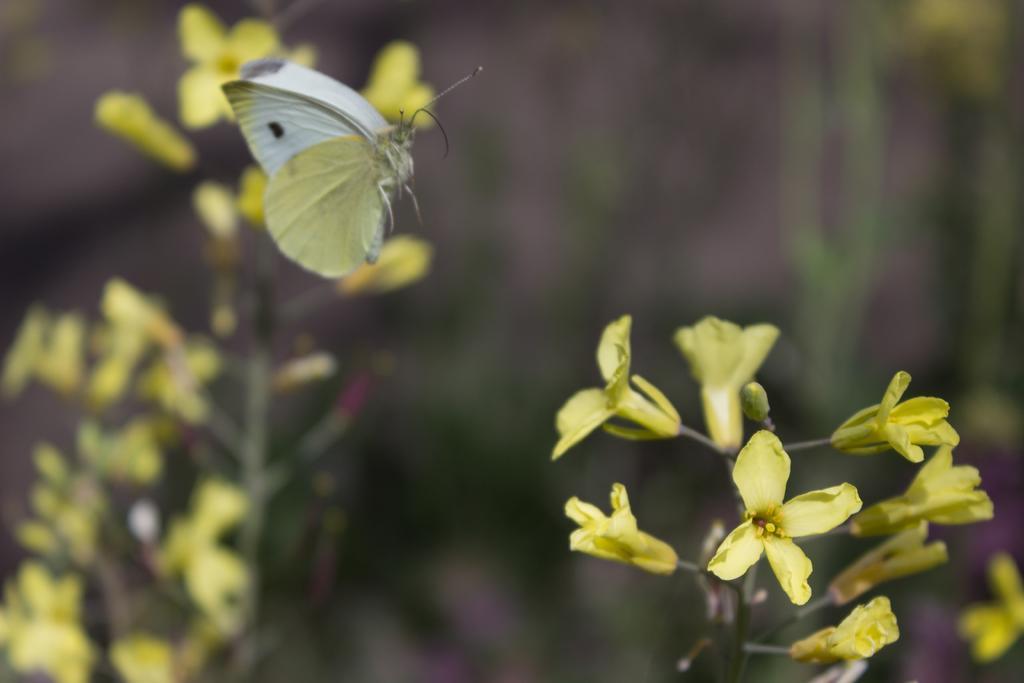In one or two sentences, can you explain what this image depicts? In this image there are flower plants. Here there is a butterfly. The background is blurry. 